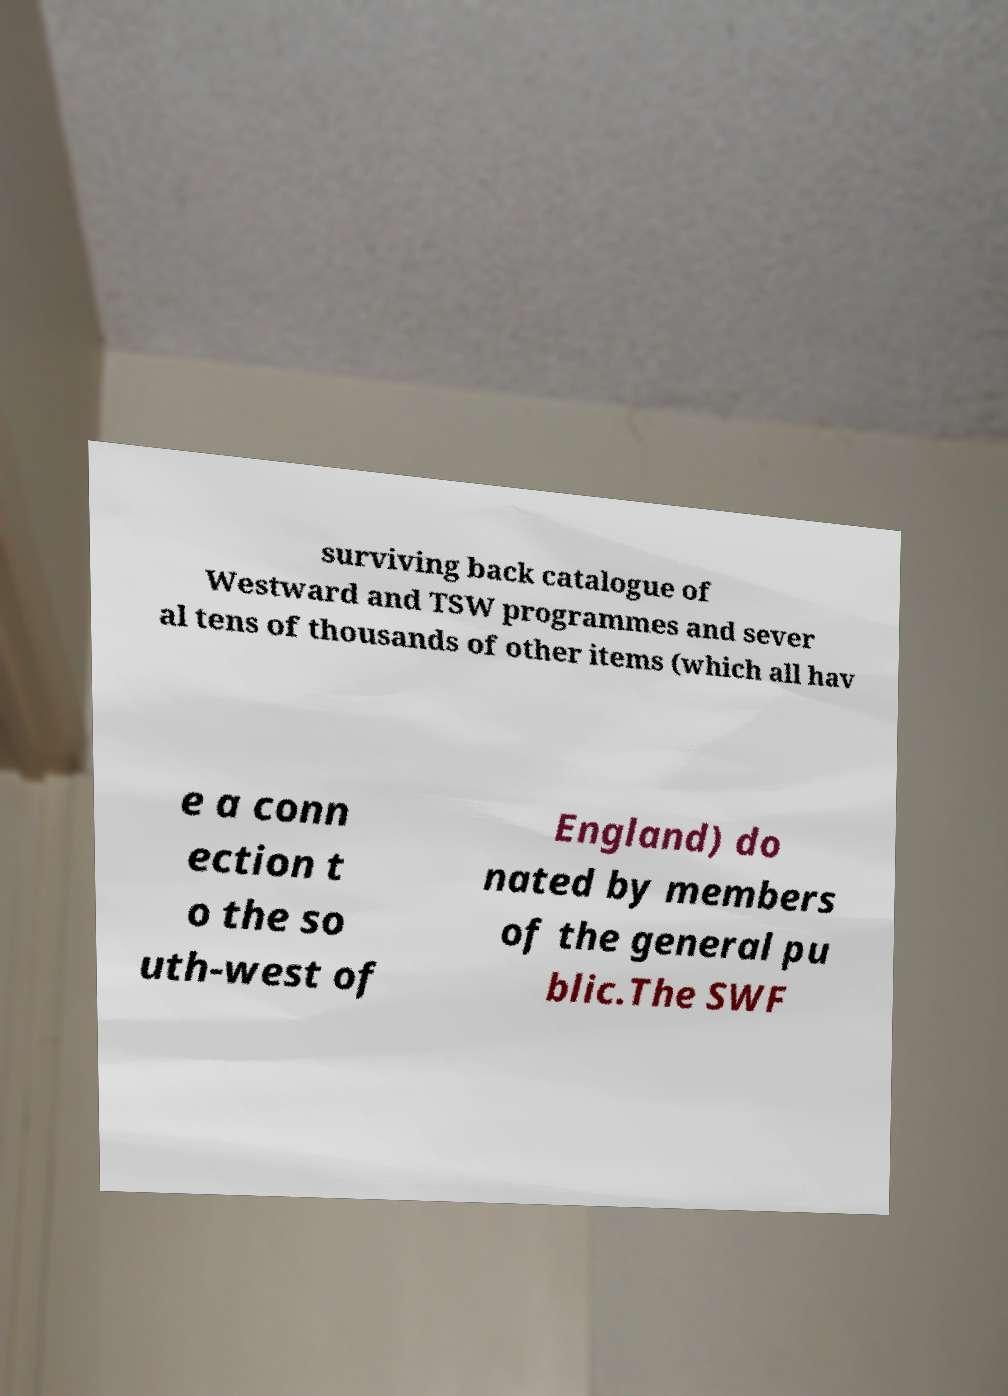I need the written content from this picture converted into text. Can you do that? surviving back catalogue of Westward and TSW programmes and sever al tens of thousands of other items (which all hav e a conn ection t o the so uth-west of England) do nated by members of the general pu blic.The SWF 